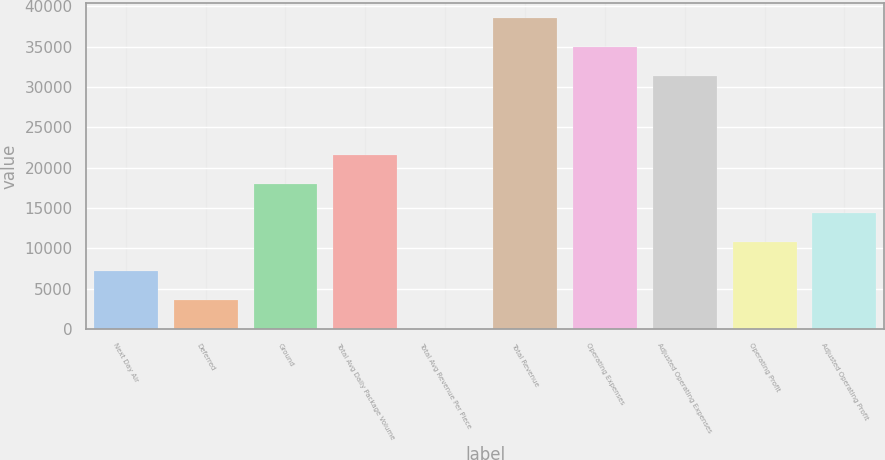Convert chart. <chart><loc_0><loc_0><loc_500><loc_500><bar_chart><fcel>Next Day Air<fcel>Deferred<fcel>Ground<fcel>Total Avg Daily Package Volume<fcel>Total Avg Revenue Per Piece<fcel>Total Revenue<fcel>Operating Expenses<fcel>Adjusted Operating Expenses<fcel>Operating Profit<fcel>Adjusted Operating Profit<nl><fcel>7177.6<fcel>3593.43<fcel>17930.1<fcel>21514.3<fcel>9.25<fcel>38510.4<fcel>34926.2<fcel>31342<fcel>10761.8<fcel>14346<nl></chart> 